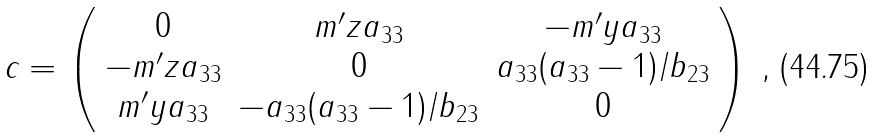<formula> <loc_0><loc_0><loc_500><loc_500>c = \left ( \begin{array} { c c c } 0 & m ^ { \prime } z a _ { 3 3 } & - m ^ { \prime } y a _ { 3 3 } \\ - m ^ { \prime } z a _ { 3 3 } & 0 & a _ { 3 3 } ( a _ { 3 3 } - 1 ) / b _ { 2 3 } \\ m ^ { \prime } y a _ { 3 3 } & - a _ { 3 3 } ( a _ { 3 3 } - 1 ) / b _ { 2 3 } & 0 \end{array} \right ) \, ,</formula> 